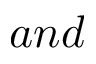Convert formula to latex. <formula><loc_0><loc_0><loc_500><loc_500>a n d</formula> 